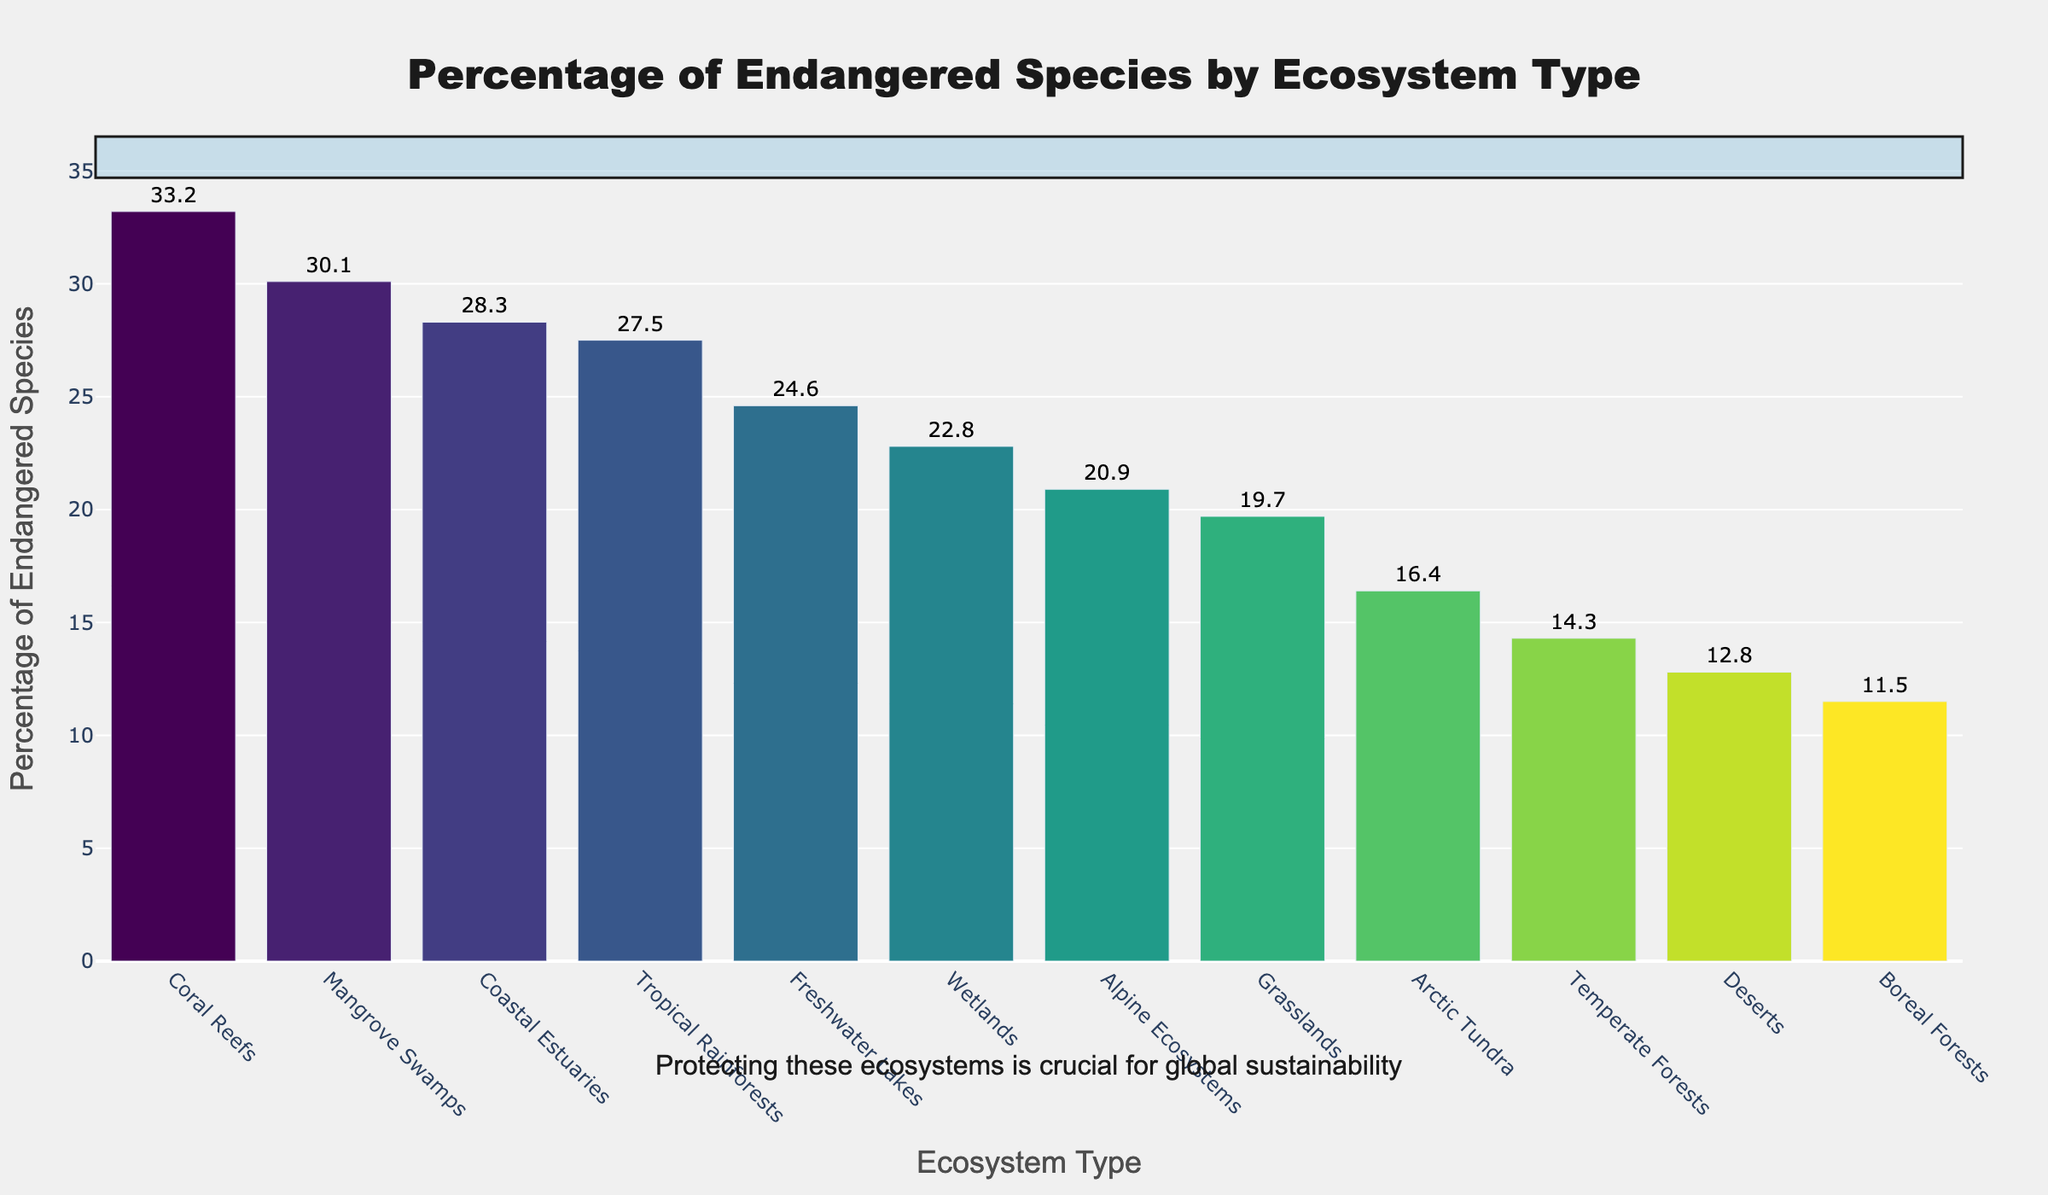Which ecosystem type has the highest percentage of endangered species? The bar chart shows that Coral Reefs have the tallest bar, signifying the highest percentage of endangered species.
Answer: Coral Reefs Which ecosystem type has the lowest percentage of endangered species? The bar chart shows that Boreal Forests have the shortest bar, indicating the lowest percentage of endangered species.
Answer: Boreal Forests What is the difference in percentage of endangered species between Coral Reefs and Boreal Forests? Coral Reefs have 33.2% and Boreal Forests have 11.5%. Subtracting these, 33.2 - 11.5 = 21.7%.
Answer: 21.7% Are there any ecosystem types with endangered species percentages above 30%? The bar chart shows Coral Reefs (33.2%) and Mangrove Swamps (30.1%) have bars above the 30% mark.
Answer: Yes, Coral Reefs and Mangrove Swamps Rank the top three ecosystem types by percentage of endangered species. By looking at the heights of the bars, the top three are: Coral Reefs (33.2%), Mangrove Swamps (30.1%), and Coastal Estuaries (28.3%).
Answer: Coral Reefs, Mangrove Swamps, Coastal Estuaries What is the combined percentage of endangered species in the three forest ecosystems (Tropical Rainforests, Temperate Forests, Boreal Forests)? The percentages are Tropical Rainforests (27.5%), Temperate Forests (14.3%), Boreal Forests (11.5%). Sum them up: 27.5 + 14.3 + 11.5 = 53.3%.
Answer: 53.3% Which ecosystem type has nearly double the percentage of endangered species compared to Deserts? Deserts have 12.8%. Arctic Tundra is close to double with 16.4%, but Mangrove Swamps at 30.1% is closer to exactly double: 12.8 * 2 = 25.6%. Mangrove Swamps are almost double that percentage.
Answer: Mangrove Swamps Is the percentage of endangered species in Freshwater Lakes closer to that in Wetlands or Temperate Forests? Freshwater Lakes have 24.6%. Wetlands are 22.8%, and Temperate Forests are 14.3%. The difference with Wetlands is 24.6 - 22.8 = 1.8%, and with Temperate Forests is 24.6 - 14.3 = 10.3%. Freshwater Lakes are closer to Wetlands.
Answer: Wetlands What is the average percentage of endangered species in Coastal Estuaries, Wetlands, and Grasslands? Coastal Estuaries have 28.3%, Wetlands have 22.8%, and Grasslands have 19.7%. The sum is 28.3 + 22.8 + 19.7 = 70.8%; the average is 70.8 / 3 ≈ 23.6%.
Answer: 23.6% How much higher is the percentage of endangered species in Tropical Rainforests compared to Temperate Forests? Tropical Rainforests have 27.5% and Temperate Forests have 14.3%. Subtracting these, 27.5 - 14.3 = 13.2%.
Answer: 13.2% 